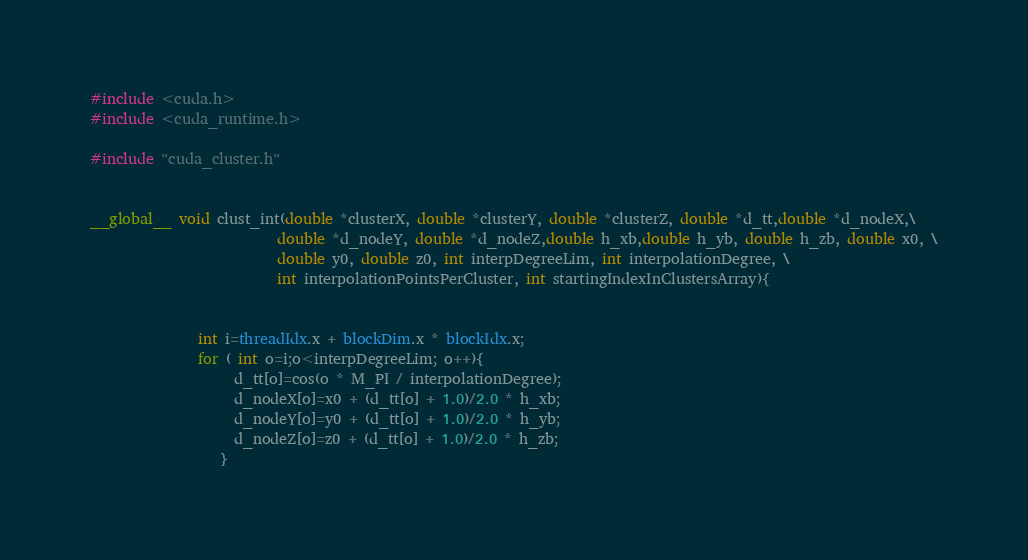Convert code to text. <code><loc_0><loc_0><loc_500><loc_500><_Cuda_>#include <cuda.h>
#include <cuda_runtime.h>

#include "cuda_cluster.h"


__global__ void clust_int(double *clusterX, double *clusterY, double *clusterZ, double *d_tt,double *d_nodeX,\
                          double *d_nodeY, double *d_nodeZ,double h_xb,double h_yb, double h_zb, double x0, \
                          double y0, double z0, int interpDegreeLim, int interpolationDegree, \
                          int interpolationPointsPerCluster, int startingIndexInClustersArray){


               int i=threadIdx.x + blockDim.x * blockIdx.x;
               for ( int o=i;o<interpDegreeLim; o++){
                    d_tt[o]=cos(o * M_PI / interpolationDegree);
                    d_nodeX[o]=x0 + (d_tt[o] + 1.0)/2.0 * h_xb;
                    d_nodeY[o]=y0 + (d_tt[o] + 1.0)/2.0 * h_yb;
                    d_nodeZ[o]=z0 + (d_tt[o] + 1.0)/2.0 * h_zb;
                  }</code> 